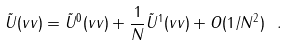Convert formula to latex. <formula><loc_0><loc_0><loc_500><loc_500>\tilde { U } ( v v ) = \tilde { U } ^ { 0 } ( v v ) + \frac { 1 } { N } \tilde { U } ^ { 1 } ( v v ) + O ( 1 / N ^ { 2 } ) \ .</formula> 